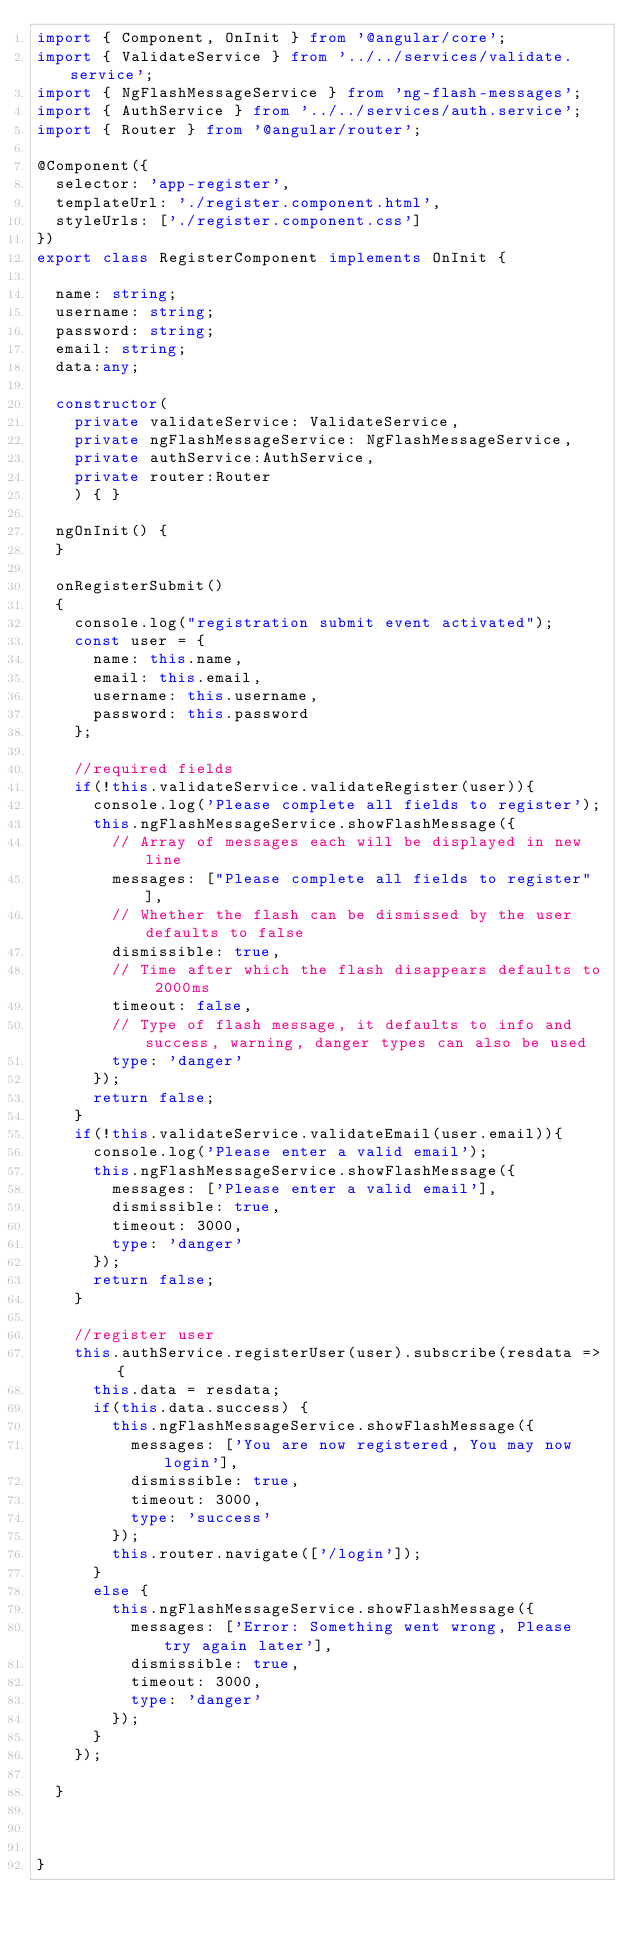<code> <loc_0><loc_0><loc_500><loc_500><_TypeScript_>import { Component, OnInit } from '@angular/core';
import { ValidateService } from '../../services/validate.service';
import { NgFlashMessageService } from 'ng-flash-messages';
import { AuthService } from '../../services/auth.service';
import { Router } from '@angular/router';

@Component({
  selector: 'app-register',
  templateUrl: './register.component.html',
  styleUrls: ['./register.component.css']
})
export class RegisterComponent implements OnInit {

  name: string;
  username: string;
  password: string;
  email: string;
  data:any;

  constructor(
    private validateService: ValidateService, 
    private ngFlashMessageService: NgFlashMessageService,
    private authService:AuthService,
    private router:Router
    ) { }

  ngOnInit() {
  }

  onRegisterSubmit()
  {
    console.log("registration submit event activated");
    const user = {
      name: this.name,
      email: this.email,
      username: this.username,
      password: this.password
    };

    //required fields
    if(!this.validateService.validateRegister(user)){
      console.log('Please complete all fields to register');
      this.ngFlashMessageService.showFlashMessage({
        // Array of messages each will be displayed in new line
        messages: ["Please complete all fields to register"], 
        // Whether the flash can be dismissed by the user defaults to false
        dismissible: true, 
        // Time after which the flash disappears defaults to 2000ms
        timeout: false,
        // Type of flash message, it defaults to info and success, warning, danger types can also be used
        type: 'danger'
      });
      return false;
    }
    if(!this.validateService.validateEmail(user.email)){
      console.log('Please enter a valid email');
      this.ngFlashMessageService.showFlashMessage({
        messages: ['Please enter a valid email'], 
        dismissible: true, 
        timeout: 3000,
        type: 'danger'
      });
      return false;
    }

    //register user
    this.authService.registerUser(user).subscribe(resdata => {
      this.data = resdata; 
      if(this.data.success) {
        this.ngFlashMessageService.showFlashMessage({
          messages: ['You are now registered, You may now login'], 
          dismissible: true, 
          timeout: 3000,
          type: 'success'
        });
        this.router.navigate(['/login']);
      }
      else {
        this.ngFlashMessageService.showFlashMessage({
          messages: ['Error: Something went wrong, Please try again later'], 
          dismissible: true, 
          timeout: 3000,
          type: 'danger'
        });
      }
    });

  }

  

}
</code> 